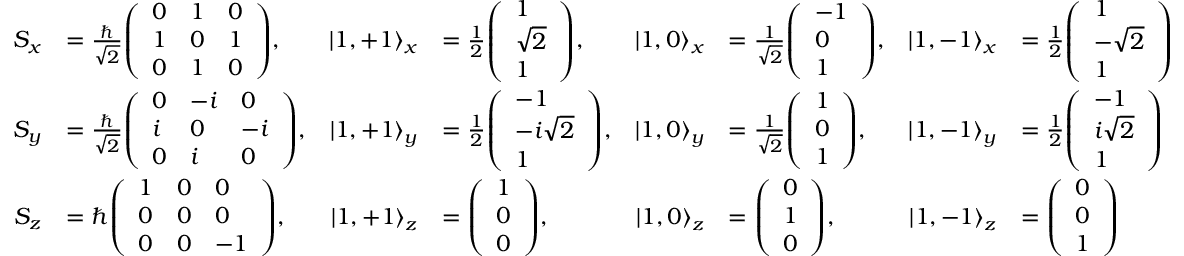<formula> <loc_0><loc_0><loc_500><loc_500>{ \begin{array} { r l r l r l r l } { S _ { x } } & { = { \frac { } { \sqrt { 2 } } } { \left ( \begin{array} { l l l } { 0 } & { 1 } & { 0 } \\ { 1 } & { 0 } & { 1 } \\ { 0 } & { 1 } & { 0 } \end{array} \right ) } , } & { \left | 1 , + 1 \right \rangle _ { x } } & { = { \frac { 1 } { 2 } } { \left ( \begin{array} { l } { 1 } \\ { { \sqrt { 2 } } } \\ { 1 } \end{array} \right ) } , } & { \left | 1 , 0 \right \rangle _ { x } } & { = { \frac { 1 } { \sqrt { 2 } } } { \left ( \begin{array} { l } { - 1 } \\ { 0 } \\ { 1 } \end{array} \right ) } , } & { \left | 1 , - 1 \right \rangle _ { x } } & { = { \frac { 1 } { 2 } } { \left ( \begin{array} { l } { 1 } \\ { { - { \sqrt { 2 } } } } \\ { 1 } \end{array} \right ) } } \\ { S _ { y } } & { = { \frac { } { \sqrt { 2 } } } { \left ( \begin{array} { l l l } { 0 } & { - i } & { 0 } \\ { i } & { 0 } & { - i } \\ { 0 } & { i } & { 0 } \end{array} \right ) } , } & { \left | 1 , + 1 \right \rangle _ { y } } & { = { \frac { 1 } { 2 } } { \left ( \begin{array} { l } { - 1 } \\ { - i { \sqrt { 2 } } } \\ { 1 } \end{array} \right ) } , } & { \left | 1 , 0 \right \rangle _ { y } } & { = { \frac { 1 } { \sqrt { 2 } } } { \left ( \begin{array} { l } { 1 } \\ { 0 } \\ { 1 } \end{array} \right ) } , } & { \left | 1 , - 1 \right \rangle _ { y } } & { = { \frac { 1 } { 2 } } { \left ( \begin{array} { l } { - 1 } \\ { i { \sqrt { 2 } } } \\ { 1 } \end{array} \right ) } } \\ { S _ { z } } & { = \hbar { \left ( \begin{array} { l l l } { 1 } & { 0 } & { 0 } \\ { 0 } & { 0 } & { 0 } \\ { 0 } & { 0 } & { - 1 } \end{array} \right ) } , } & { \left | 1 , + 1 \right \rangle _ { z } } & { = { \left ( \begin{array} { l } { 1 } \\ { 0 } \\ { 0 } \end{array} \right ) } , } & { \left | 1 , 0 \right \rangle _ { z } } & { = { \left ( \begin{array} { l } { 0 } \\ { 1 } \\ { 0 } \end{array} \right ) } , } & { \left | 1 , - 1 \right \rangle _ { z } } & { = { \left ( \begin{array} { l } { 0 } \\ { 0 } \\ { 1 } \end{array} \right ) } } \end{array} }</formula> 